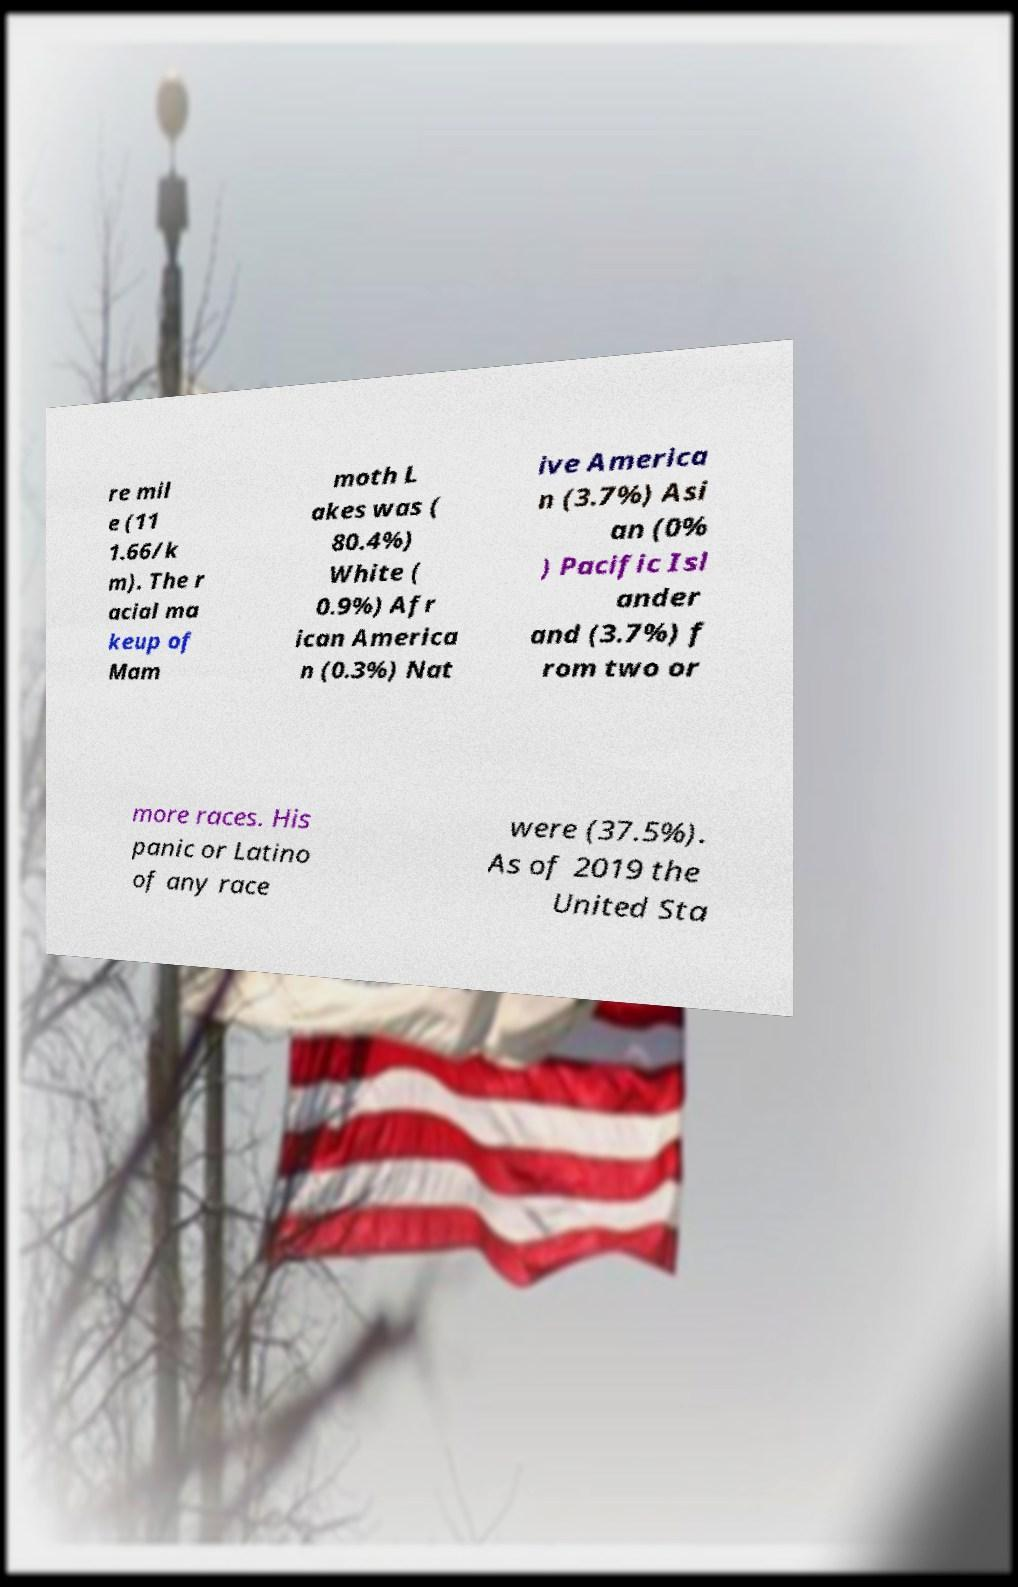I need the written content from this picture converted into text. Can you do that? re mil e (11 1.66/k m). The r acial ma keup of Mam moth L akes was ( 80.4%) White ( 0.9%) Afr ican America n (0.3%) Nat ive America n (3.7%) Asi an (0% ) Pacific Isl ander and (3.7%) f rom two or more races. His panic or Latino of any race were (37.5%). As of 2019 the United Sta 